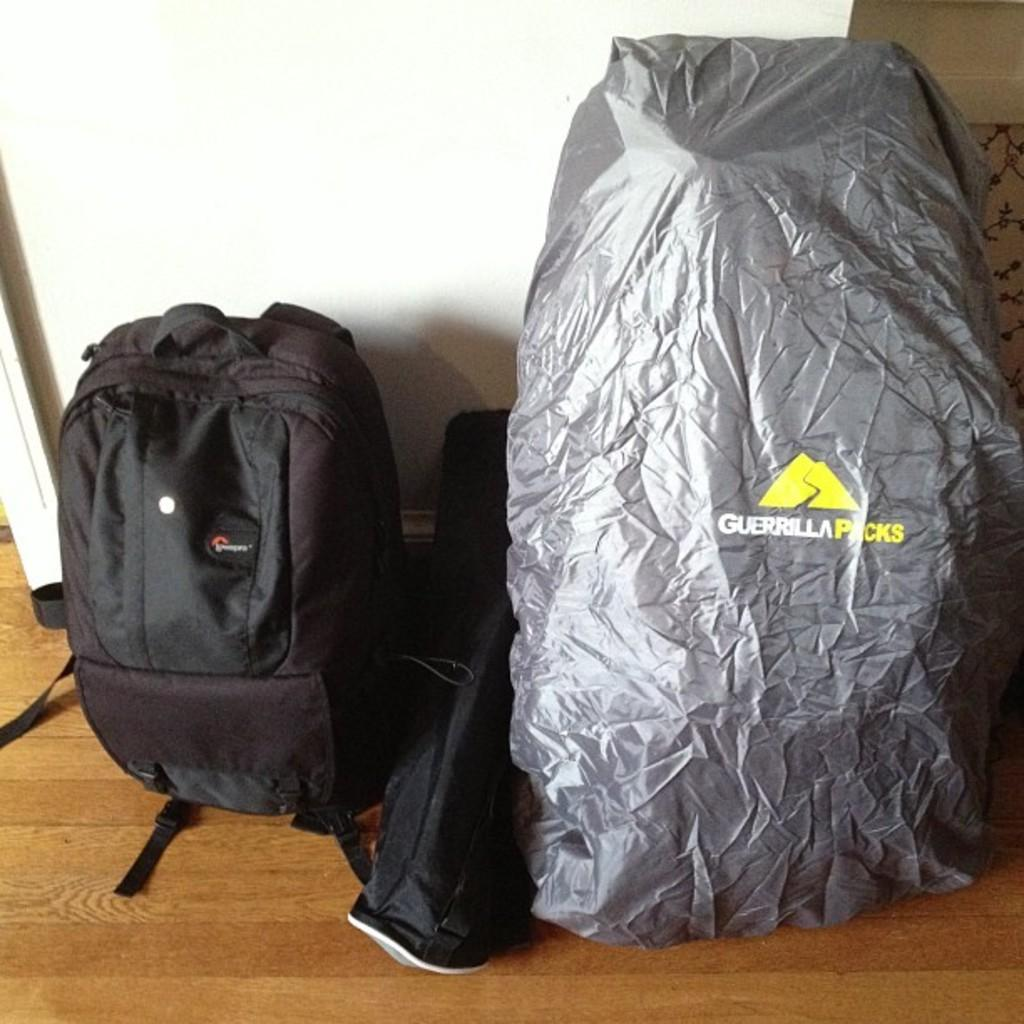<image>
Create a compact narrative representing the image presented. A backpack and large bag sit together from the company Guerrilla Packs. 